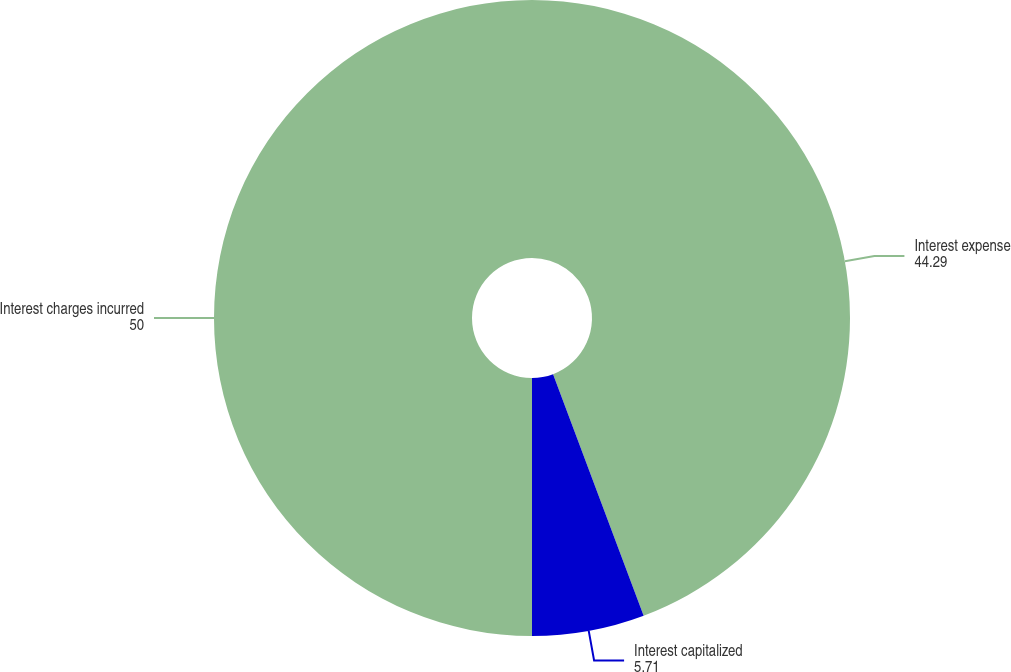Convert chart. <chart><loc_0><loc_0><loc_500><loc_500><pie_chart><fcel>Interest expense<fcel>Interest capitalized<fcel>Interest charges incurred<nl><fcel>44.29%<fcel>5.71%<fcel>50.0%<nl></chart> 